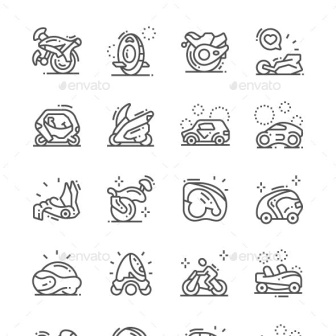Imagine a magical world where these icons are enchanted. What fantastical abilities would each mode of transportation have? In a magical world, every mode of transportation in the image would possess unique enchanted abilities. The motorcycle could traverse through mystical portals, instantly transporting riders to distant realms. The unicycle might have the ability to defy gravity, allowing the rider to ride up walls and across ceilings. The motorcycle helmet could grant the wearer enhanced vision and resistance to all elements, making it perfect for adventurous quests. The racecar might be able to accelerate to light speed, making interstellar travel possible. The futuristic enclosed vehicle might be able to shape-shift to blend into different environments, providing stealth travel. The jet ski would skim over both water and clouds, offering rides through enchanting skies. The sled might conjure icy paths wherever it goes, creating magical trails. Each enchanted vehicle would serve as a tool for heroes and adventurers, aiding in quests and explorations across the magical realm. 